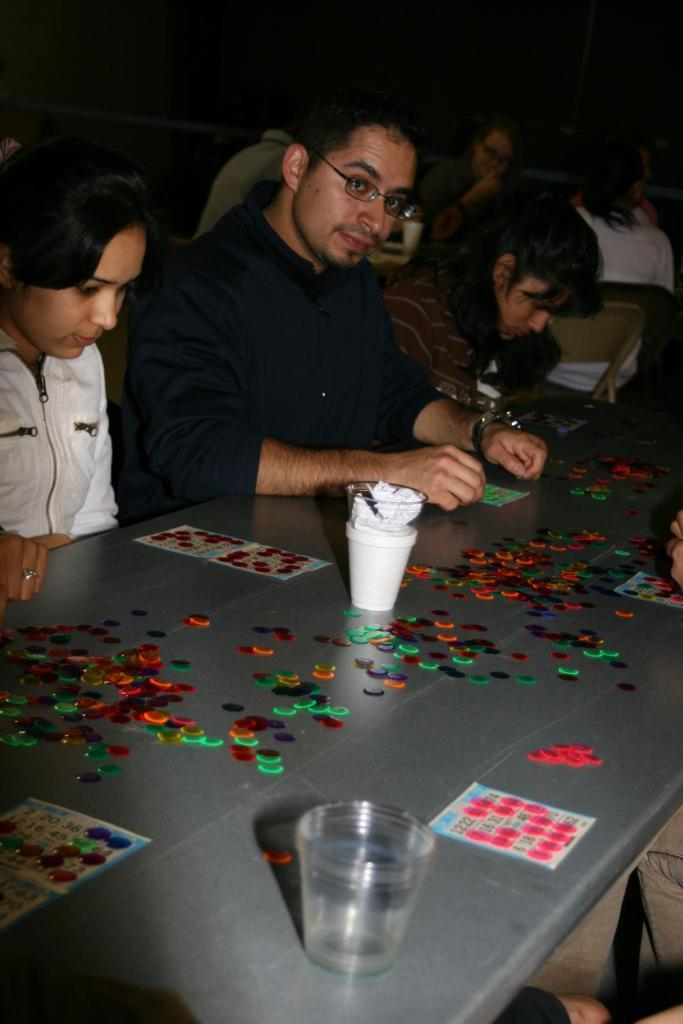What are the people in the image doing? The persons in the image are sitting on chairs. What can be seen on the table in the image? There is a glass, a cup, a bowl, and other things on the table. Can you describe the glass on the table? The glass is one of the items visible on the table. What type of voice can be heard coming from the ghost in the image? There is no ghost present in the image, so it is not possible to determine what type of voice might be heard. 